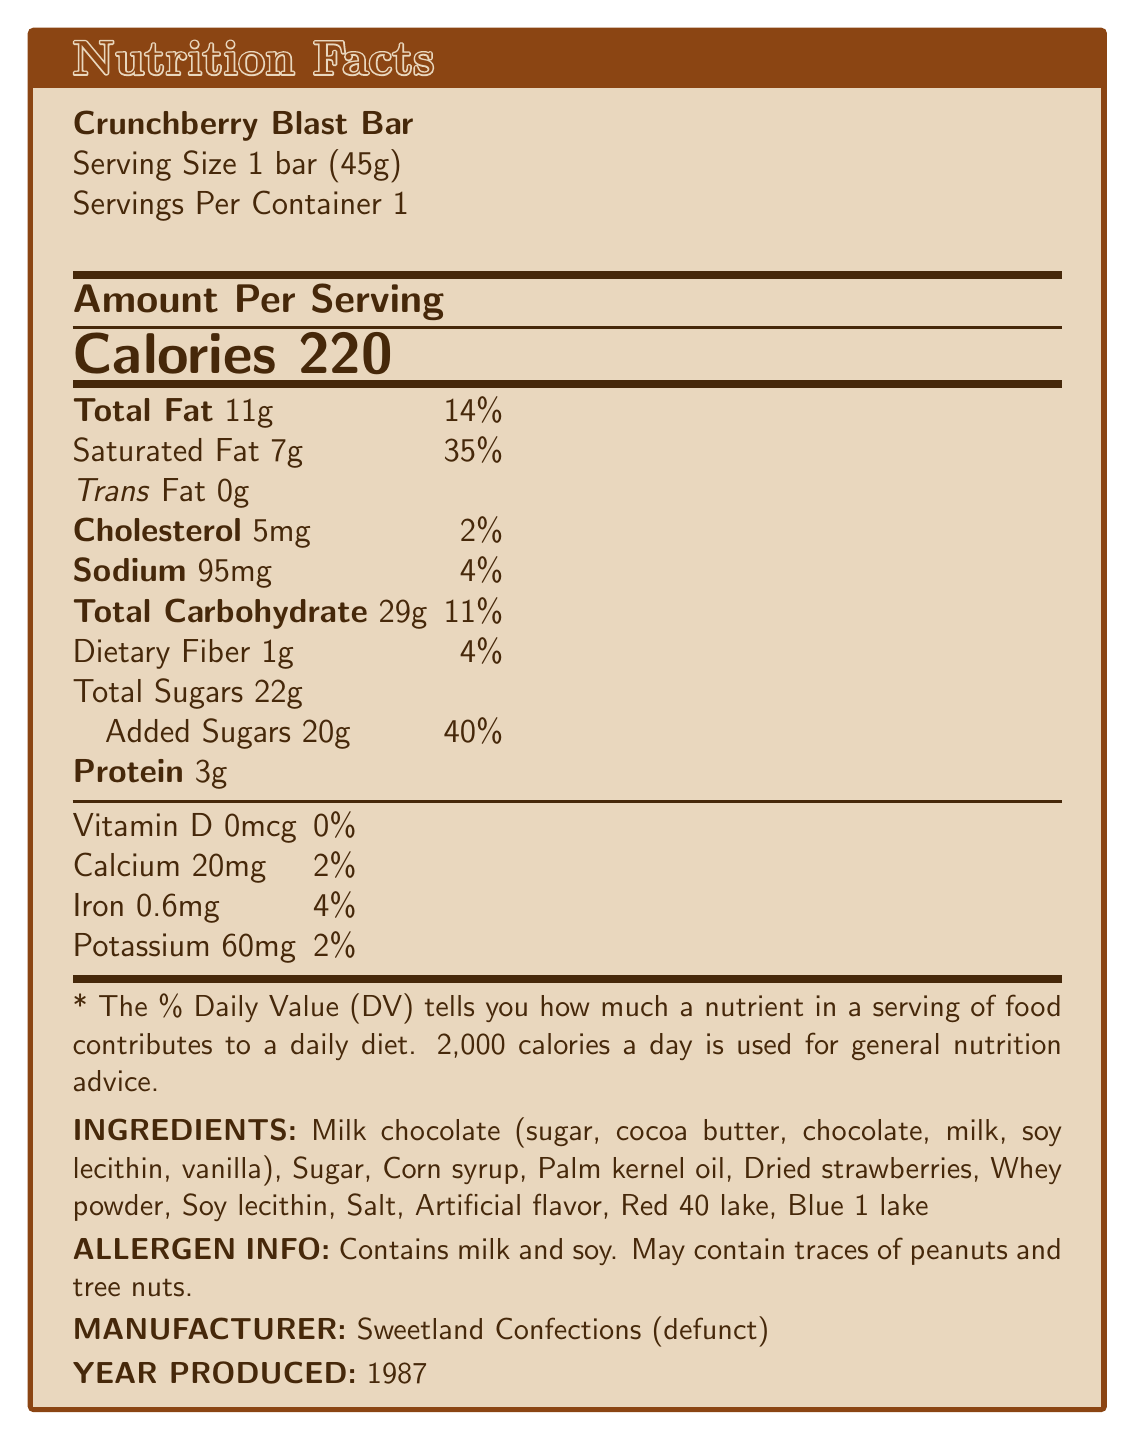What is the serving size of the Crunchberry Blast Bar? The serving size is listed as "1 bar (45g)" in the nutrition facts section.
Answer: 1 bar (45g) How many calories are in one serving of the Crunchberry Blast Bar? The nutrition facts list the caloric content as 220 calories per serving.
Answer: 220 What percentage of the daily value of saturated fat does one Crunchberry Blast Bar provide? The nutrition facts state that the bar provides 7g of saturated fat, which is 35% of the daily value.
Answer: 35% What amount of total sugars does the Crunchberry Blast Bar contain? The total sugars content is explicitly mentioned as 22g in the nutrition facts.
Answer: 22g Which year was the Crunchberry Blast Bar produced? It is stated in the document under the manufacturer section that the product was produced in 1987.
Answer: 1987 What is the amount of sodium in one serving of the Crunchberry Blast Bar? A. 95mg B. 120mg C. 75mg D. 85mg The document indicates that there are 95mg of sodium per serving.
Answer: A. 95mg How much protein is in the Crunchberry Blast Bar? The nutrition facts list the protein content as 3g per serving.
Answer: 3g Which of the following is NOT an ingredient in the Crunchberry Blast Bar? A. Palm kernel oil B. Dried strawberries C. Red 40 lake D. Natural flavor The listed ingredients include palm kernel oil, dried strawberries, and Red 40 lake, but not natural flavor.
Answer: D. Natural flavor Does the Crunchberry Blast Bar contain any allergens? The allergen information specifies that the bar contains milk and soy and may contain traces of peanuts and tree nuts.
Answer: Yes Summarize the main details provided in the document. This summary captures the product details, nutritional content, ingredients, allergen information, and collector notes including its rarity, condition importance, authenticity markers, and estimated value.
Answer: The Crunchberry Blast Bar, manufactured by the defunct Sweetland Confections in 1987, is a 45g candy bar with 220 calories per serving. The nutrition facts include 11g of total fat, 29g of total carbohydrates, 22g of sugars, and 3g of protein. It contains ingredients such as milk chocolate, corn syrup, and dried strawberries, and has allergens like milk and soy. Collector notes highlight its rarity, unopened packaging, and authenticity markers, estimating its value between $150-$200 in mint condition. What is the daily value percentage for calcium in the Crunchberry Blast Bar? The nutrition facts indicate that the bar contains 20mg of calcium, which is 2% of the daily value.
Answer: 2% How many grams of dietary fiber does the Crunchberry Blast Bar contain? The nutrition facts list 1g of dietary fiber per serving.
Answer: 1g What is the batch number of the Crunchberry Blast Bar? According to the collector notes, the batch number stamped on the bottom of the packaging is 87C452.
Answer: 87C452 What is the estimated value range for a mint condition Crunchberry Blast Bar? The collector notes estimate the value of an unopened, mint-condition bar to be between $150 and $200.
Answer: $150-$200 What are the key authenticity markers for the Crunchberry Blast Bar? The document states the authenticity markers as a holographic 'SC' logo on the wrapper, the batch number stamped on the bottom (87C452), and a unique 'berry burst' aroma when the package is lightly scratched.
Answer: Holographic 'SC' logo on wrapper, batch number 87C452, unique 'berry burst' aroma Which company manufactured the Crunchberry Blast Bar and what is its current status? The document notes that Sweetland Confections, the manufacturer of the bar, is now defunct.
Answer: Sweetland Confections, defunct Is palm kernel oil an ingredient in the Crunchberry Blast Bar? The list of ingredients includes palm kernel oil.
Answer: Yes What is the total percentage daily value of carbohydrates in one serving of the Crunchberry Blast Bar? The nutrition facts indicate that the bar contains 29g of total carbohydrates, which is 11% of the daily value.
Answer: 11% What is the historical significance of the Crunchberry Blast Bar in relation to Sweetland Confections? The collector notes mention that it was the last product released before Sweetland Confections went bankrupt.
Answer: Last product released before bankruptcy What is the company’s history or reason for being defunct? The document does not provide specific details on the history or reasons behind the company's closure.
Answer: Cannot be determined 